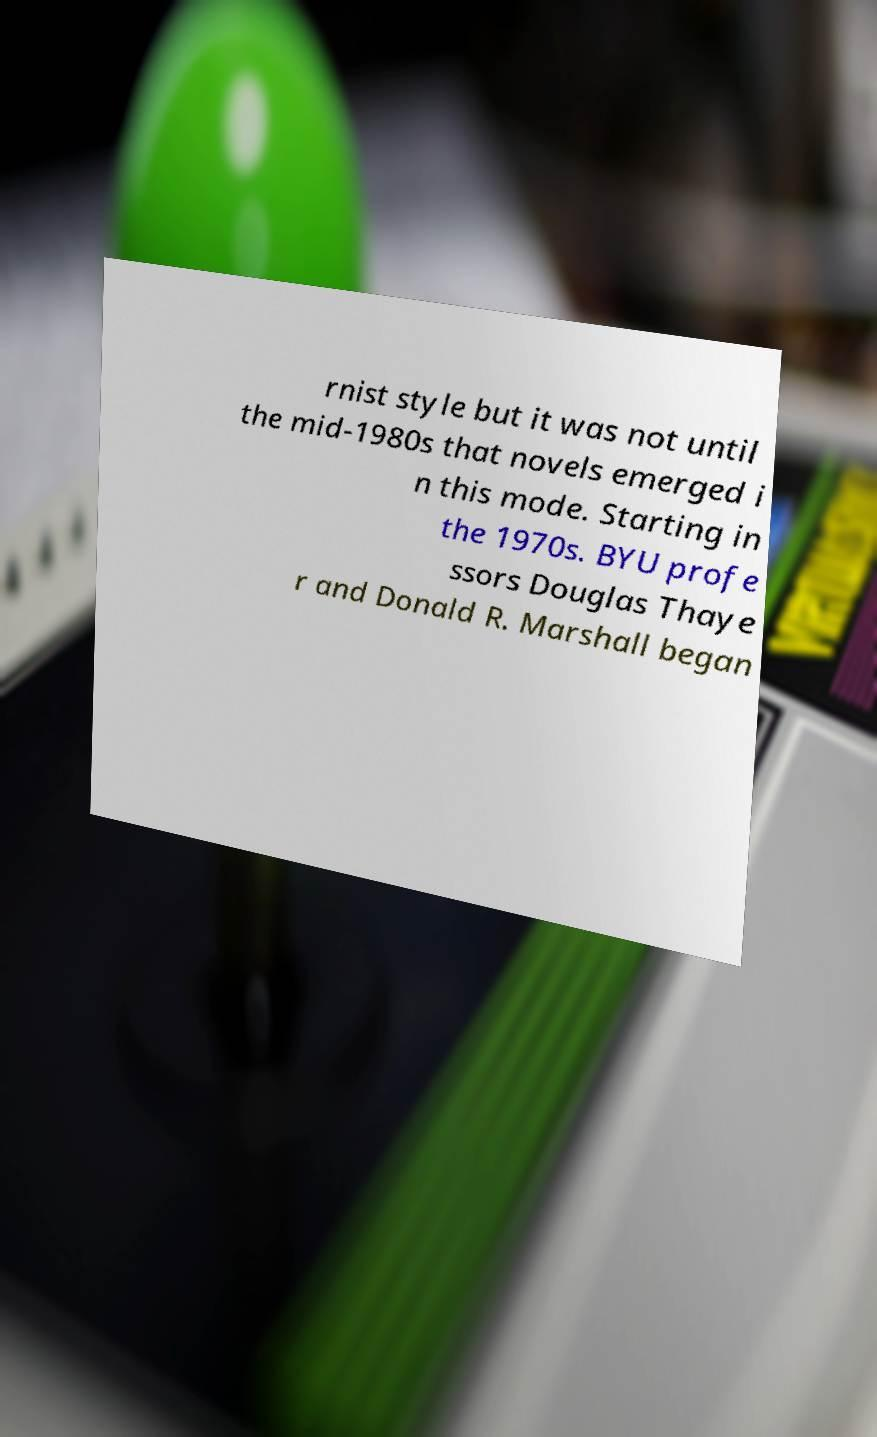Could you assist in decoding the text presented in this image and type it out clearly? rnist style but it was not until the mid-1980s that novels emerged i n this mode. Starting in the 1970s. BYU profe ssors Douglas Thaye r and Donald R. Marshall began 